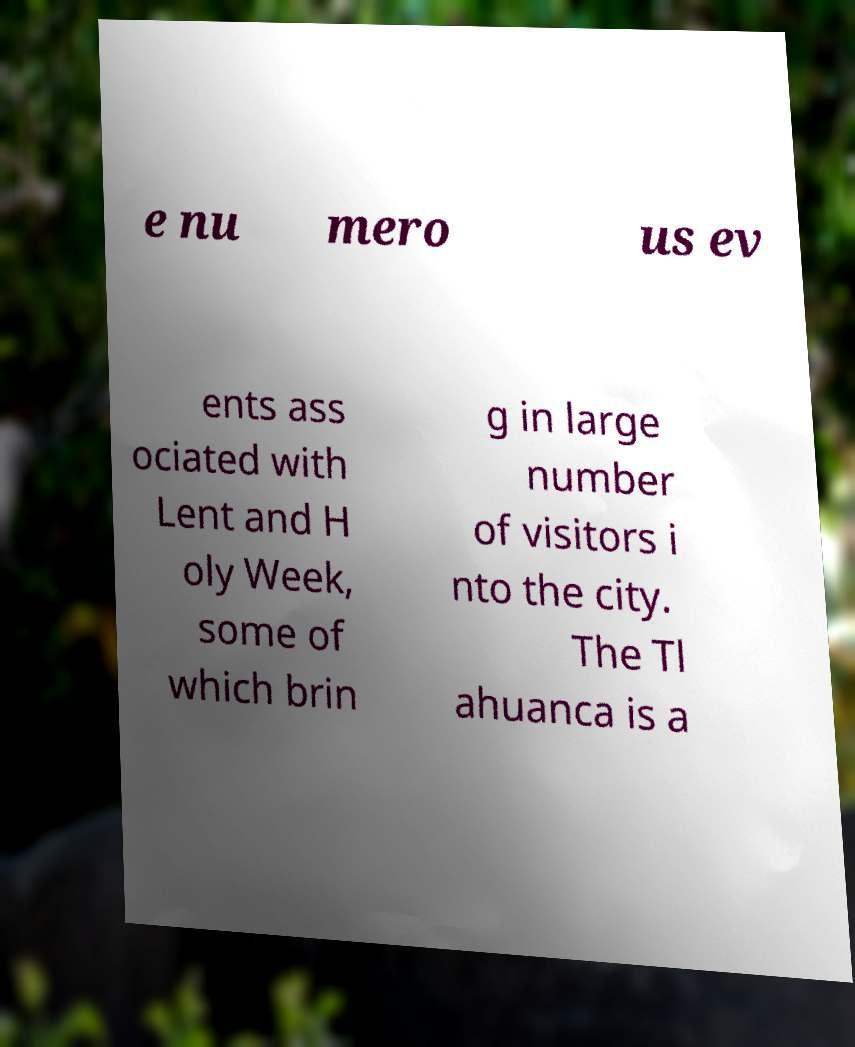Can you read and provide the text displayed in the image?This photo seems to have some interesting text. Can you extract and type it out for me? e nu mero us ev ents ass ociated with Lent and H oly Week, some of which brin g in large number of visitors i nto the city. The Tl ahuanca is a 